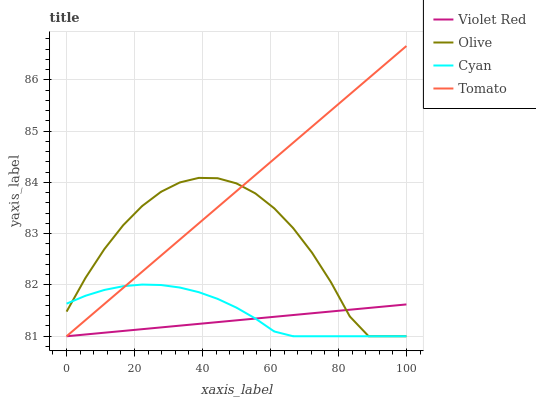Does Violet Red have the minimum area under the curve?
Answer yes or no. Yes. Does Tomato have the maximum area under the curve?
Answer yes or no. Yes. Does Cyan have the minimum area under the curve?
Answer yes or no. No. Does Cyan have the maximum area under the curve?
Answer yes or no. No. Is Violet Red the smoothest?
Answer yes or no. Yes. Is Olive the roughest?
Answer yes or no. Yes. Is Cyan the smoothest?
Answer yes or no. No. Is Cyan the roughest?
Answer yes or no. No. Does Olive have the lowest value?
Answer yes or no. Yes. Does Tomato have the highest value?
Answer yes or no. Yes. Does Cyan have the highest value?
Answer yes or no. No. Does Tomato intersect Cyan?
Answer yes or no. Yes. Is Tomato less than Cyan?
Answer yes or no. No. Is Tomato greater than Cyan?
Answer yes or no. No. 